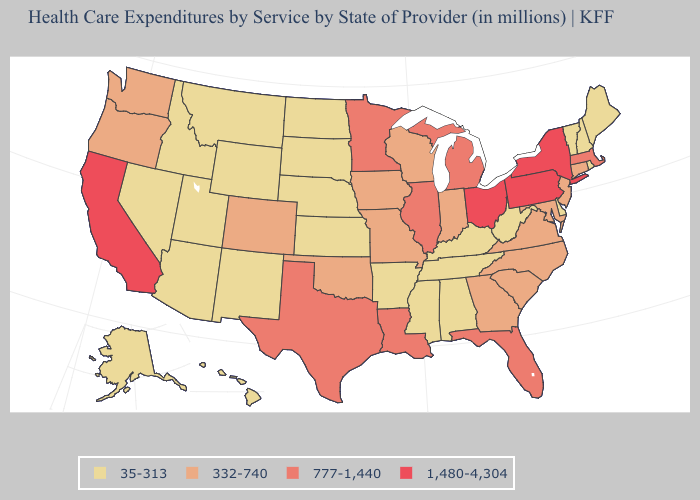What is the highest value in states that border South Carolina?
Concise answer only. 332-740. Among the states that border Mississippi , which have the lowest value?
Concise answer only. Alabama, Arkansas, Tennessee. Does Alabama have the lowest value in the USA?
Short answer required. Yes. Name the states that have a value in the range 332-740?
Answer briefly. Colorado, Connecticut, Georgia, Indiana, Iowa, Maryland, Missouri, New Jersey, North Carolina, Oklahoma, Oregon, South Carolina, Virginia, Washington, Wisconsin. Which states hav the highest value in the MidWest?
Write a very short answer. Ohio. Name the states that have a value in the range 777-1,440?
Quick response, please. Florida, Illinois, Louisiana, Massachusetts, Michigan, Minnesota, Texas. Is the legend a continuous bar?
Be succinct. No. Which states hav the highest value in the Northeast?
Answer briefly. New York, Pennsylvania. Among the states that border Tennessee , which have the highest value?
Answer briefly. Georgia, Missouri, North Carolina, Virginia. Among the states that border Kentucky , which have the lowest value?
Short answer required. Tennessee, West Virginia. What is the value of Texas?
Short answer required. 777-1,440. Does Idaho have a lower value than Alaska?
Be succinct. No. What is the value of Illinois?
Answer briefly. 777-1,440. Name the states that have a value in the range 332-740?
Give a very brief answer. Colorado, Connecticut, Georgia, Indiana, Iowa, Maryland, Missouri, New Jersey, North Carolina, Oklahoma, Oregon, South Carolina, Virginia, Washington, Wisconsin. How many symbols are there in the legend?
Give a very brief answer. 4. 